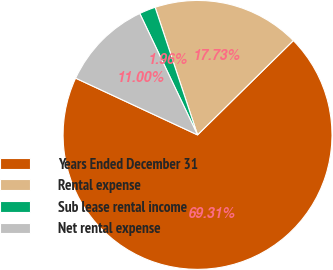<chart> <loc_0><loc_0><loc_500><loc_500><pie_chart><fcel>Years Ended December 31<fcel>Rental expense<fcel>Sub lease rental income<fcel>Net rental expense<nl><fcel>69.31%<fcel>17.73%<fcel>1.96%<fcel>11.0%<nl></chart> 